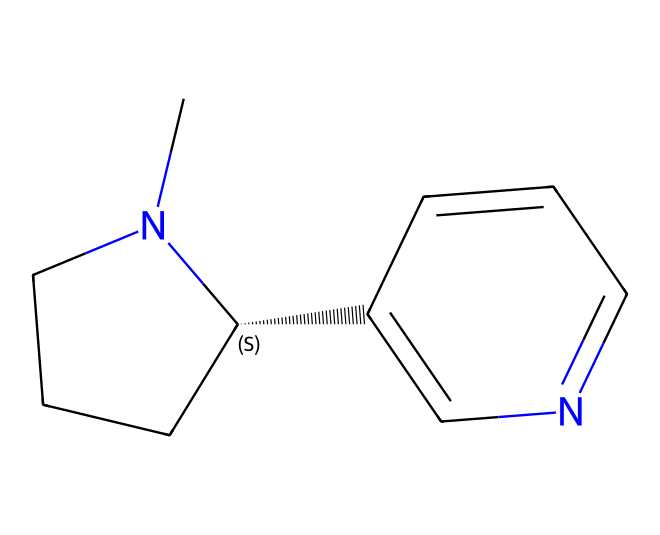What is the molecular formula of nicotine? To determine the molecular formula, we identify the number of each type of atom in the SMILES representation. The structure indicates a total of 10 carbon (C) atoms, 14 hydrogen (H) atoms, and 2 nitrogen (N) atoms. Therefore, the molecular formula is C10H14N2.
Answer: C10H14N2 How many rings are present in the structure? The SMILES indicates that there are two cycles. By analyzing the structure, we can see that there are two separate ring systems formed by the atom connections.
Answer: 2 What type of functional groups are present? The structure includes a nitrogen-containing heterocycle, indicating the presence of amine and pyridine functional groups. There are both saturated and aromatic characteristics due to the types of bonds and rings involved.
Answer: amine, pyridine Is nicotine a saturated or unsaturated compound? By examining the number of double bonds in the structure, it is observed that there are aromatic parts, which indicate the presence of unsaturation in the compound. Thus, nicotine is classified as unsaturated.
Answer: unsaturated What is the chiral center present in nicotine? The SMILES notation contains a specific chiral center indicated by the '@' symbol, which refers to the carbon atom connected to four different groups. Analyzing this reveals that the carbon atom at position 4 is the chiral center.
Answer: carbon at position 4 What class of compounds does nicotine belong to? Nicotine fits into the category of alkaloids, which are naturally occurring compounds that mostly contain basic nitrogen atoms. Its structure and activity confirm its classification as an alkaloid.
Answer: alkaloid 